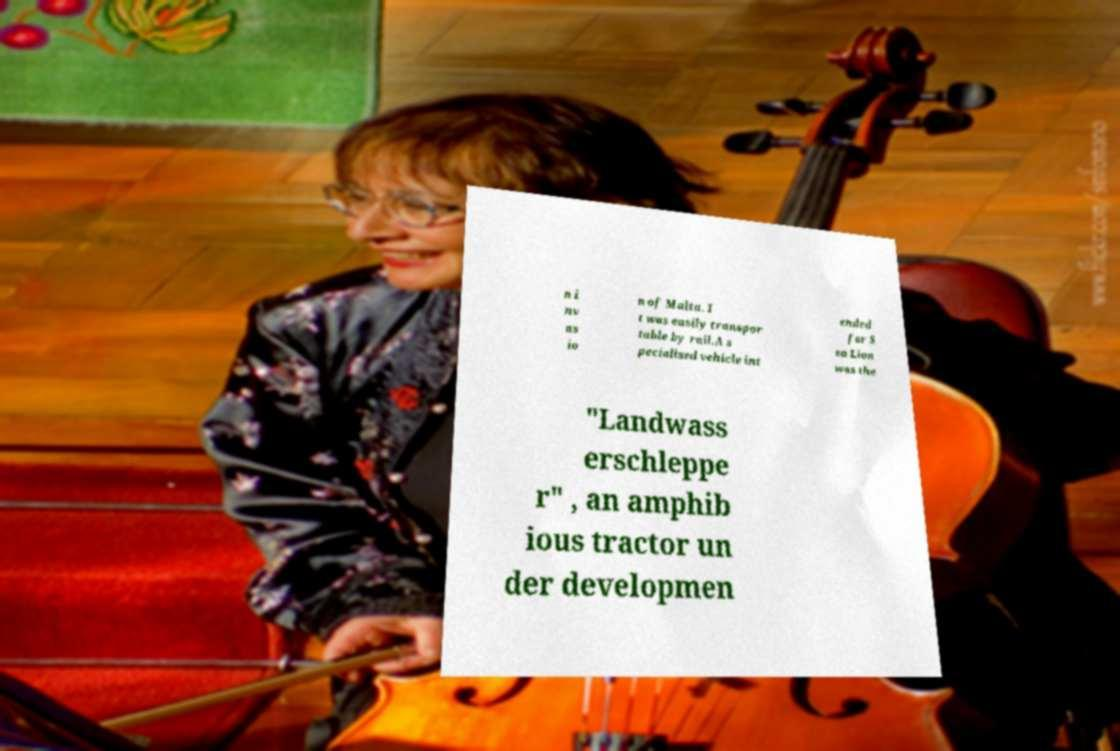Can you accurately transcribe the text from the provided image for me? n i nv as io n of Malta. I t was easily transpor table by rail.A s pecialised vehicle int ended for S ea Lion was the "Landwass erschleppe r" , an amphib ious tractor un der developmen 